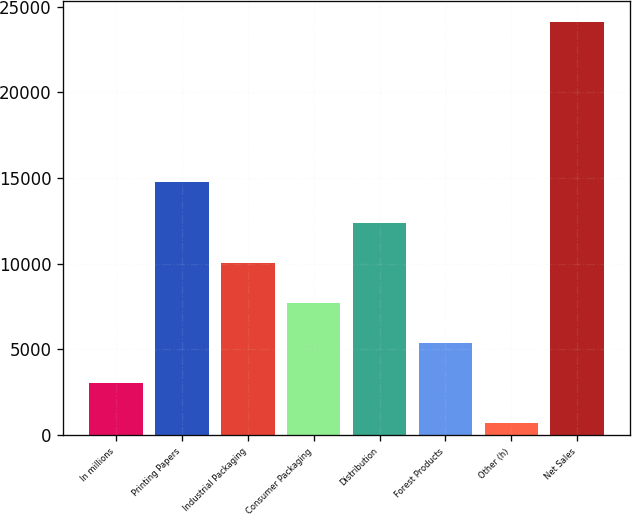Convert chart. <chart><loc_0><loc_0><loc_500><loc_500><bar_chart><fcel>In millions<fcel>Printing Papers<fcel>Industrial Packaging<fcel>Consumer Packaging<fcel>Distribution<fcel>Forest Products<fcel>Other (h)<fcel>Net Sales<nl><fcel>3040.6<fcel>14738.6<fcel>10059.4<fcel>7719.8<fcel>12399<fcel>5380.2<fcel>701<fcel>24097<nl></chart> 